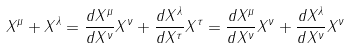<formula> <loc_0><loc_0><loc_500><loc_500>X ^ { \mu } + X ^ { \lambda } = \frac { d X ^ { \mu } } { d X ^ { \nu } } X ^ { \nu } + \frac { d X ^ { \lambda } } { d X ^ { \tau } } X ^ { \tau } = \frac { d X ^ { \mu } } { d X ^ { \nu } } X ^ { \nu } + \frac { d X ^ { \lambda } } { d X ^ { \nu } } X ^ { \nu }</formula> 